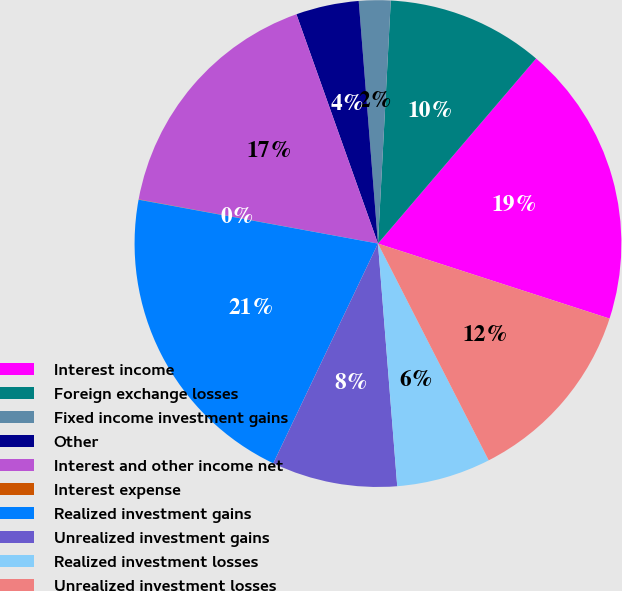Convert chart. <chart><loc_0><loc_0><loc_500><loc_500><pie_chart><fcel>Interest income<fcel>Foreign exchange losses<fcel>Fixed income investment gains<fcel>Other<fcel>Interest and other income net<fcel>Interest expense<fcel>Realized investment gains<fcel>Unrealized investment gains<fcel>Realized investment losses<fcel>Unrealized investment losses<nl><fcel>18.74%<fcel>10.42%<fcel>2.1%<fcel>4.18%<fcel>16.66%<fcel>0.02%<fcel>20.82%<fcel>8.34%<fcel>6.26%<fcel>12.5%<nl></chart> 